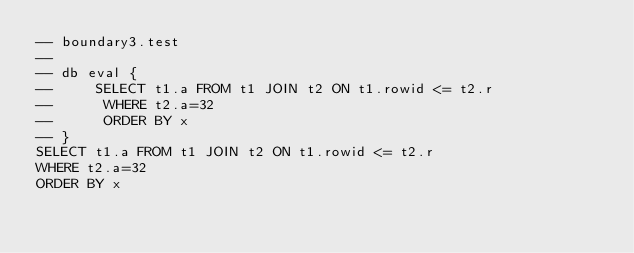<code> <loc_0><loc_0><loc_500><loc_500><_SQL_>-- boundary3.test
-- 
-- db eval {
--     SELECT t1.a FROM t1 JOIN t2 ON t1.rowid <= t2.r
--      WHERE t2.a=32
--      ORDER BY x
-- }
SELECT t1.a FROM t1 JOIN t2 ON t1.rowid <= t2.r
WHERE t2.a=32
ORDER BY x</code> 